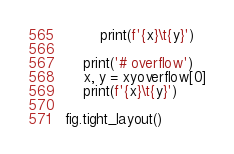Convert code to text. <code><loc_0><loc_0><loc_500><loc_500><_Python_>        print(f'{x}\t{y}')
    
    print('# overflow')
    x, y = xyoverflow[0]
    print(f'{x}\t{y}')

fig.tight_layout()
</code> 